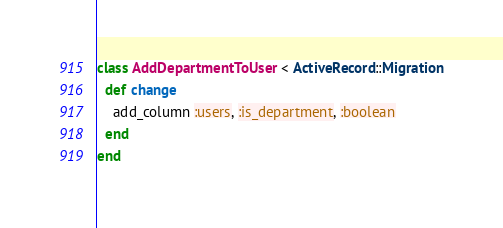Convert code to text. <code><loc_0><loc_0><loc_500><loc_500><_Ruby_>class AddDepartmentToUser < ActiveRecord::Migration
  def change
    add_column :users, :is_department, :boolean
  end
end
</code> 